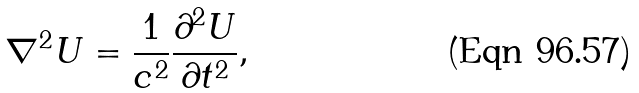<formula> <loc_0><loc_0><loc_500><loc_500>\nabla ^ { 2 } U = { \frac { 1 } { c ^ { 2 } } } { \frac { \partial ^ { 2 } U } { \partial t ^ { 2 } } } ,</formula> 